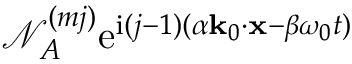Convert formula to latex. <formula><loc_0><loc_0><loc_500><loc_500>\mathcal { N } _ { A } ^ { ( m j ) } e ^ { i ( j - 1 ) ( \alpha k _ { 0 } \cdot x - \beta \omega _ { 0 } t ) }</formula> 